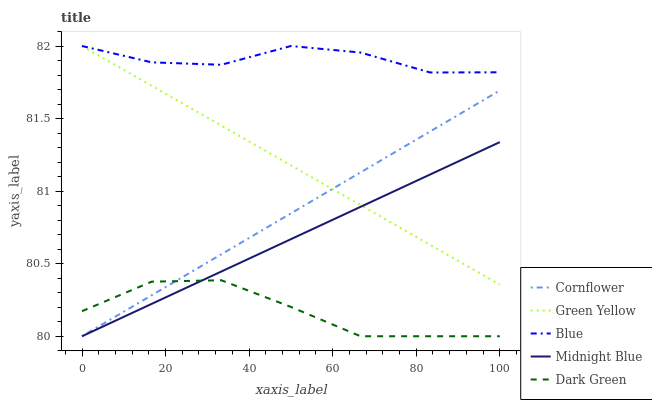Does Dark Green have the minimum area under the curve?
Answer yes or no. Yes. Does Blue have the maximum area under the curve?
Answer yes or no. Yes. Does Cornflower have the minimum area under the curve?
Answer yes or no. No. Does Cornflower have the maximum area under the curve?
Answer yes or no. No. Is Green Yellow the smoothest?
Answer yes or no. Yes. Is Blue the roughest?
Answer yes or no. Yes. Is Cornflower the smoothest?
Answer yes or no. No. Is Cornflower the roughest?
Answer yes or no. No. Does Cornflower have the lowest value?
Answer yes or no. Yes. Does Green Yellow have the lowest value?
Answer yes or no. No. Does Green Yellow have the highest value?
Answer yes or no. Yes. Does Cornflower have the highest value?
Answer yes or no. No. Is Dark Green less than Green Yellow?
Answer yes or no. Yes. Is Green Yellow greater than Dark Green?
Answer yes or no. Yes. Does Midnight Blue intersect Dark Green?
Answer yes or no. Yes. Is Midnight Blue less than Dark Green?
Answer yes or no. No. Is Midnight Blue greater than Dark Green?
Answer yes or no. No. Does Dark Green intersect Green Yellow?
Answer yes or no. No. 